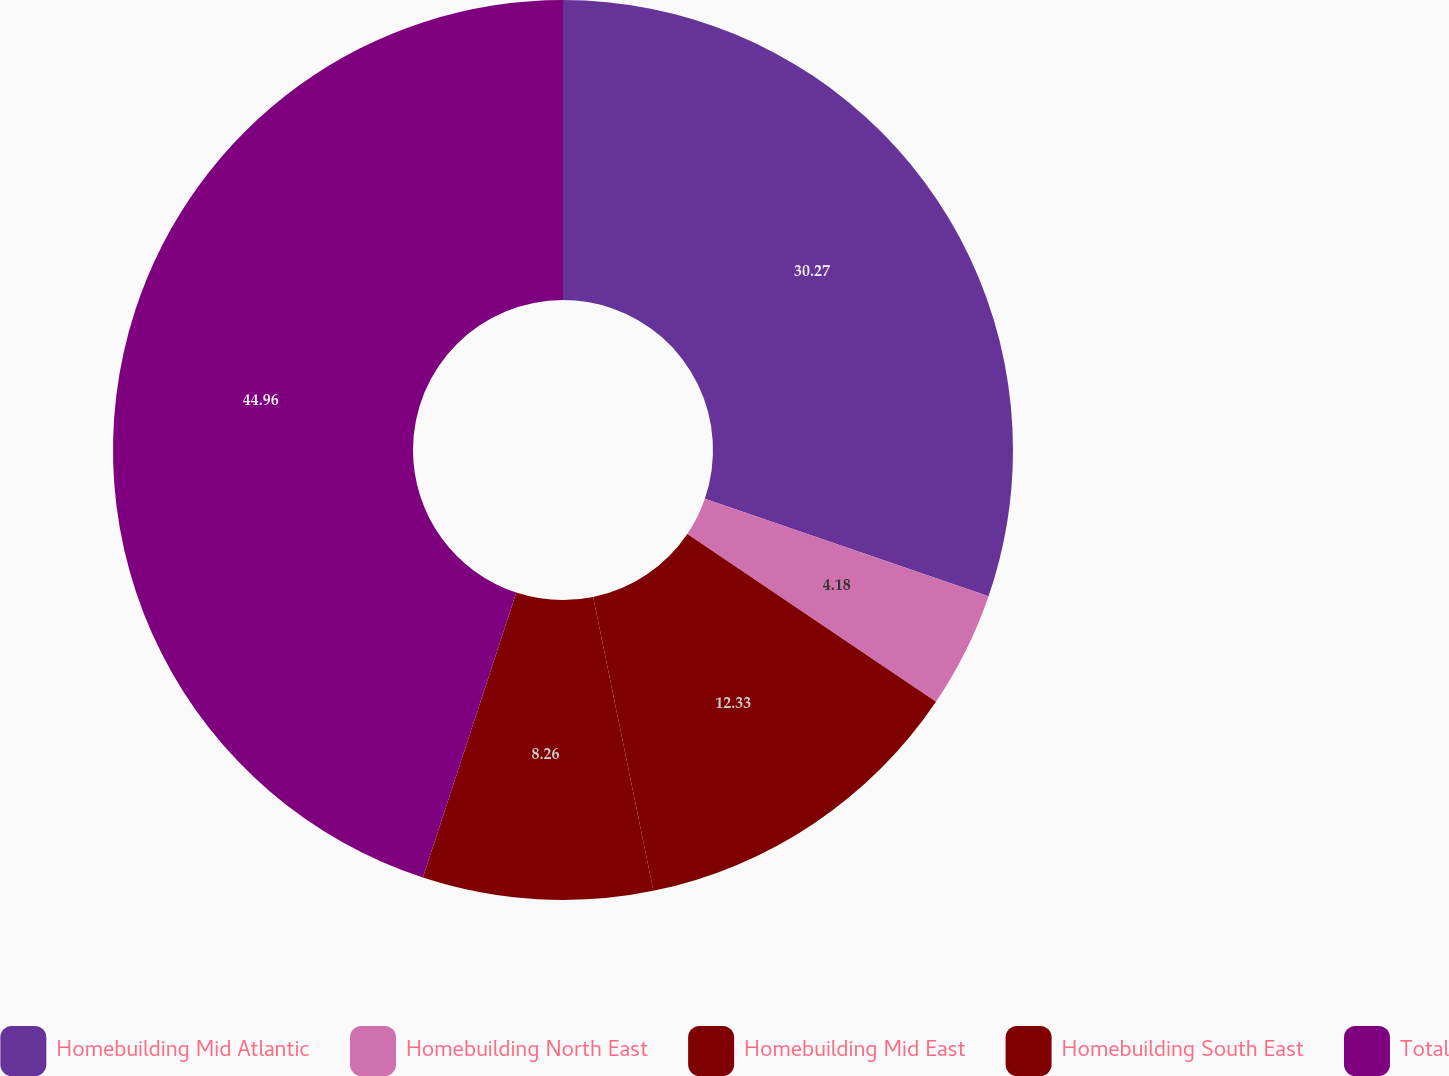<chart> <loc_0><loc_0><loc_500><loc_500><pie_chart><fcel>Homebuilding Mid Atlantic<fcel>Homebuilding North East<fcel>Homebuilding Mid East<fcel>Homebuilding South East<fcel>Total<nl><fcel>30.27%<fcel>4.18%<fcel>12.33%<fcel>8.26%<fcel>44.96%<nl></chart> 